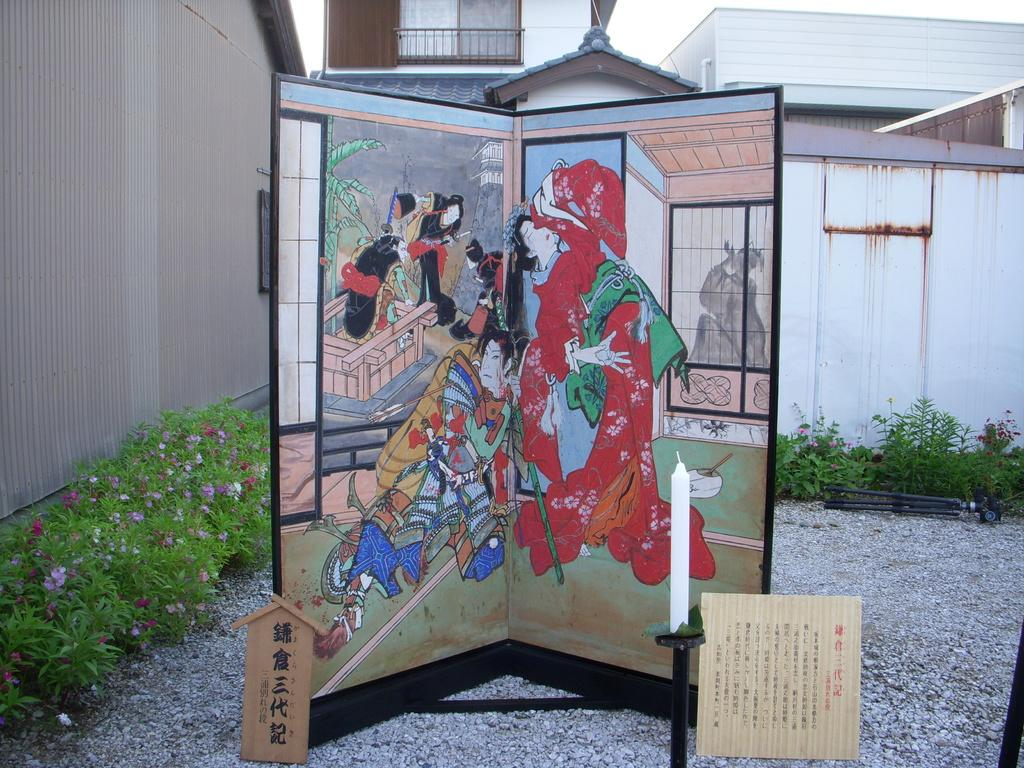What type of structures can be seen in the image? There are buildings in the image. What is hanging or attached to the buildings? There is a banner and a poster in the image. What type of vegetation is present in the image? There are plants in the image. What is visible at the top of the image? The sky is visible at the top of the image. What type of mint can be seen growing on the buildings in the image? There is no mint or any other plant growing on the buildings in the image. What sound do the tin bells make in the image? There are no bells, tin or otherwise, present in the image. 